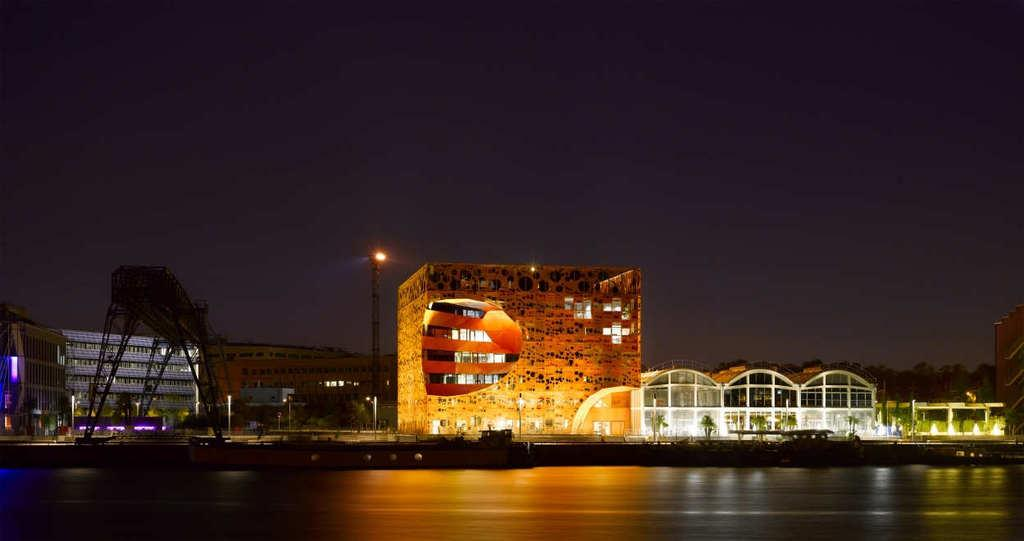What types of structures can be seen in the image? There are buildings in the image. What natural elements are present in the image? There are trees in the image. What artificial elements are present in the image? There are lights, poles, and a fence in the image. What architectural style can be observed in the image? There is an architecture in the image. What type of seating is available in the image? There are benches in the image. What is the composition of the image in terms of the ground and sky? The bottom of the image contains a floor, and the top of the image contains the sky. How many frogs are sitting on the benches in the image? There are no frogs present in the image. What type of pain is depicted in the image? There is no depiction of pain in the image. 